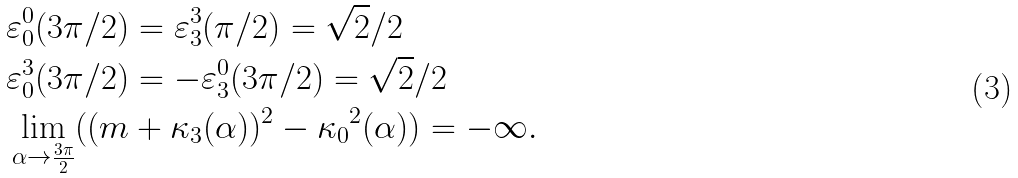Convert formula to latex. <formula><loc_0><loc_0><loc_500><loc_500>& { \varepsilon } ^ { 0 } _ { 0 } ( { 3 \pi } / { 2 } ) = { \varepsilon } ^ { 3 } _ { 3 } ( { \pi } / { 2 } ) = \sqrt { 2 } / { 2 } \\ & { \varepsilon } ^ { 3 } _ { 0 } ( { 3 \pi } / { 2 } ) = - { \varepsilon } ^ { 0 } _ { 3 } ( { 3 \pi } / { 2 } ) = \sqrt { 2 } / { 2 } \\ & \lim _ { { \alpha } \to \frac { 3 \pi } { 2 } } ( ( m + { \kappa } _ { 3 } ( \alpha ) ) ^ { 2 } - { { \kappa } _ { 0 } } ^ { 2 } ( \alpha ) ) = - \infty .</formula> 